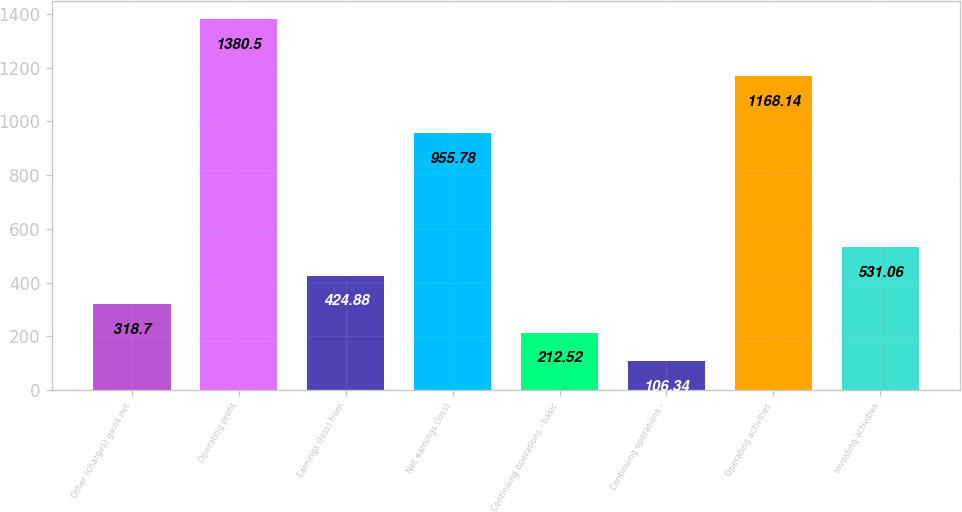Convert chart to OTSL. <chart><loc_0><loc_0><loc_500><loc_500><bar_chart><fcel>Other (charges) gains net<fcel>Operating profit<fcel>Earnings (loss) from<fcel>Net earnings (loss)<fcel>Continuing operations - basic<fcel>Continuing operations -<fcel>Operating activities<fcel>Investing activities<nl><fcel>318.7<fcel>1380.5<fcel>424.88<fcel>955.78<fcel>212.52<fcel>106.34<fcel>1168.14<fcel>531.06<nl></chart> 